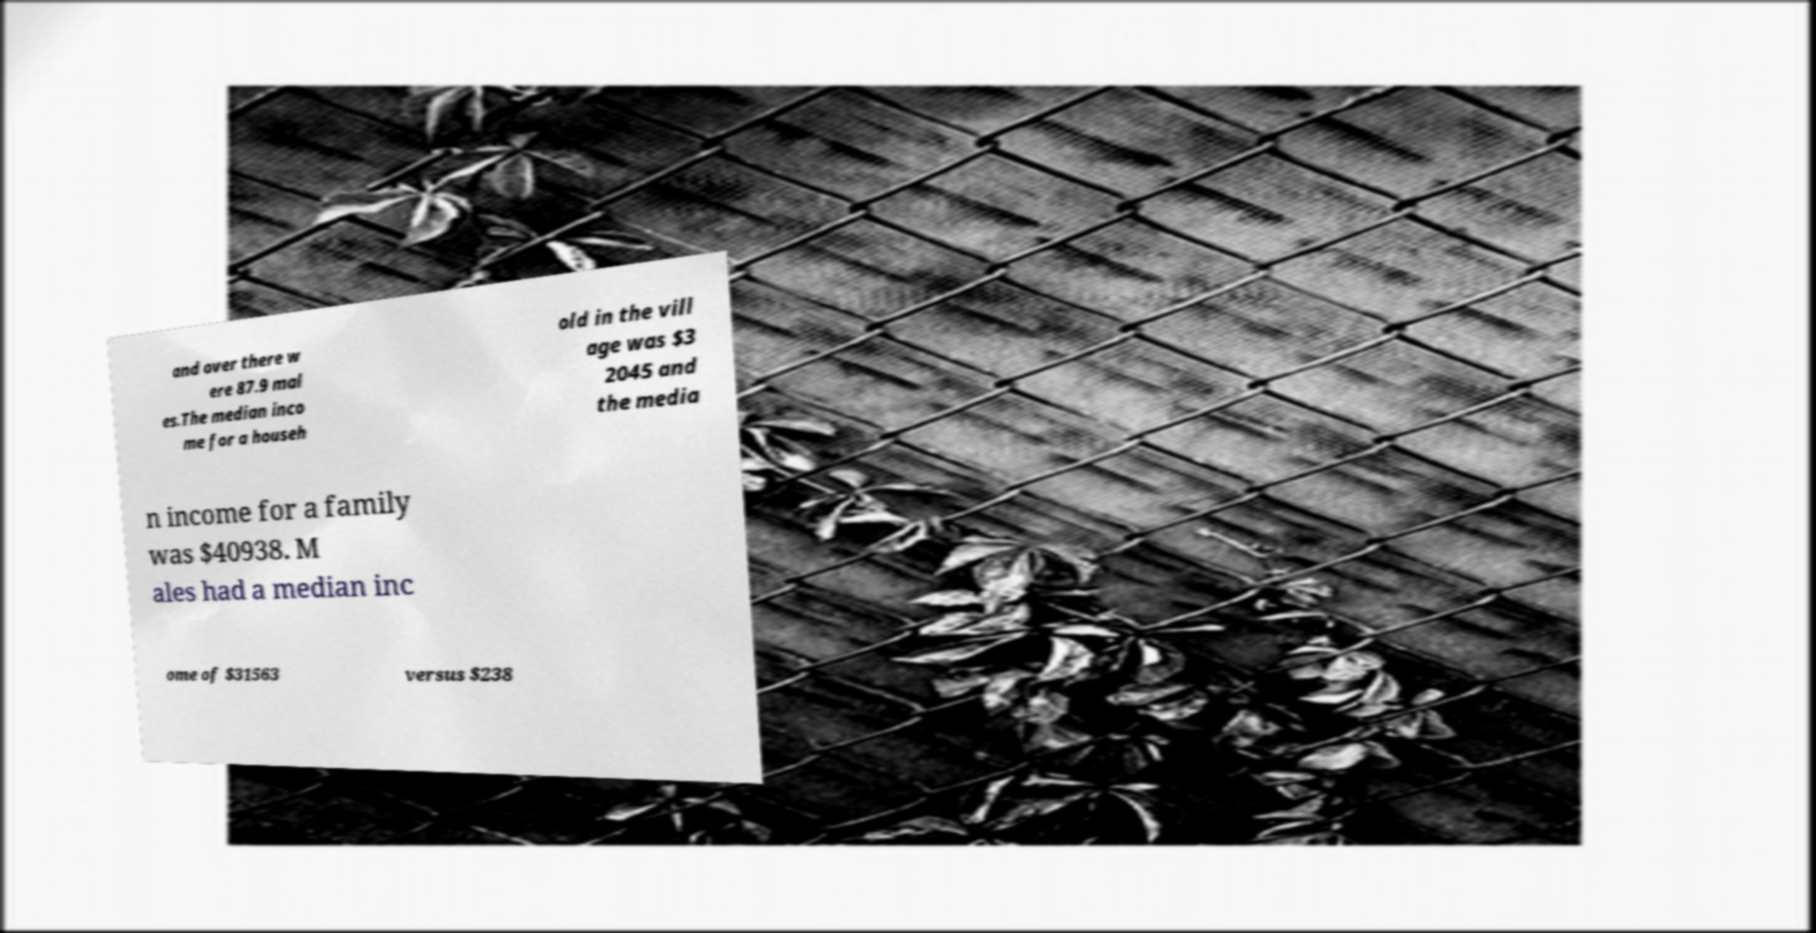I need the written content from this picture converted into text. Can you do that? and over there w ere 87.9 mal es.The median inco me for a househ old in the vill age was $3 2045 and the media n income for a family was $40938. M ales had a median inc ome of $31563 versus $238 